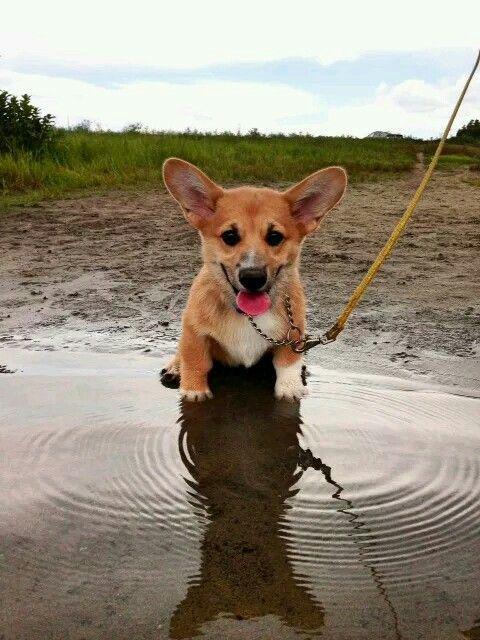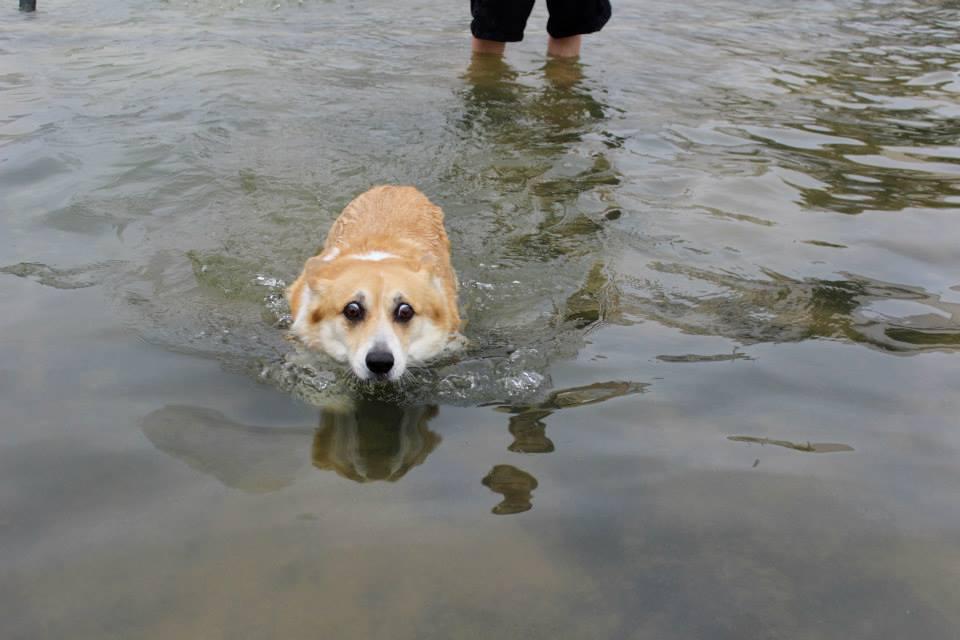The first image is the image on the left, the second image is the image on the right. For the images displayed, is the sentence "One of the dogs has a stick in its mouth." factually correct? Answer yes or no. No. The first image is the image on the left, the second image is the image on the right. Assess this claim about the two images: "One image shows at least one dog swimming forward with nothing carried in its mouth, and the other image contains one sitting dog wearing a leash.". Correct or not? Answer yes or no. Yes. 